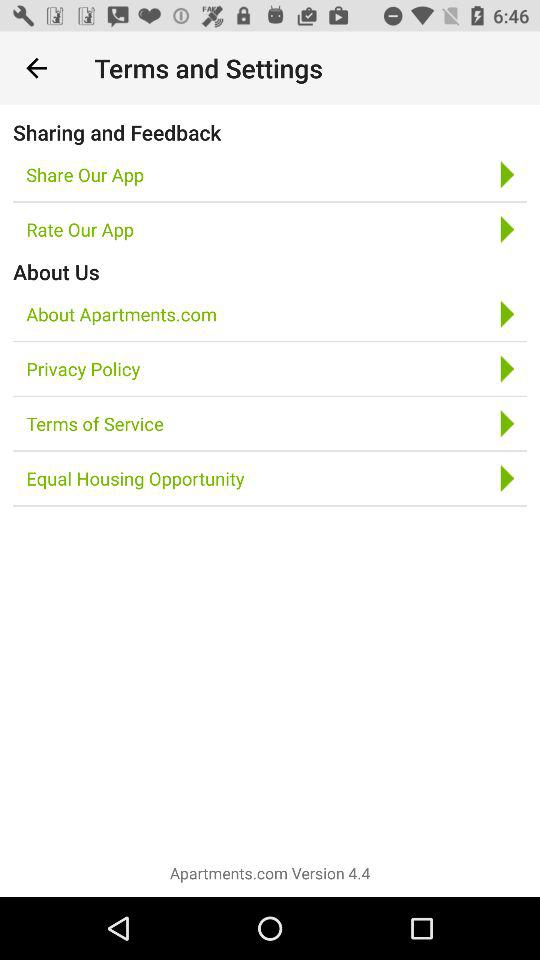What is the version of the application being used? The version of the application is 4.4. 